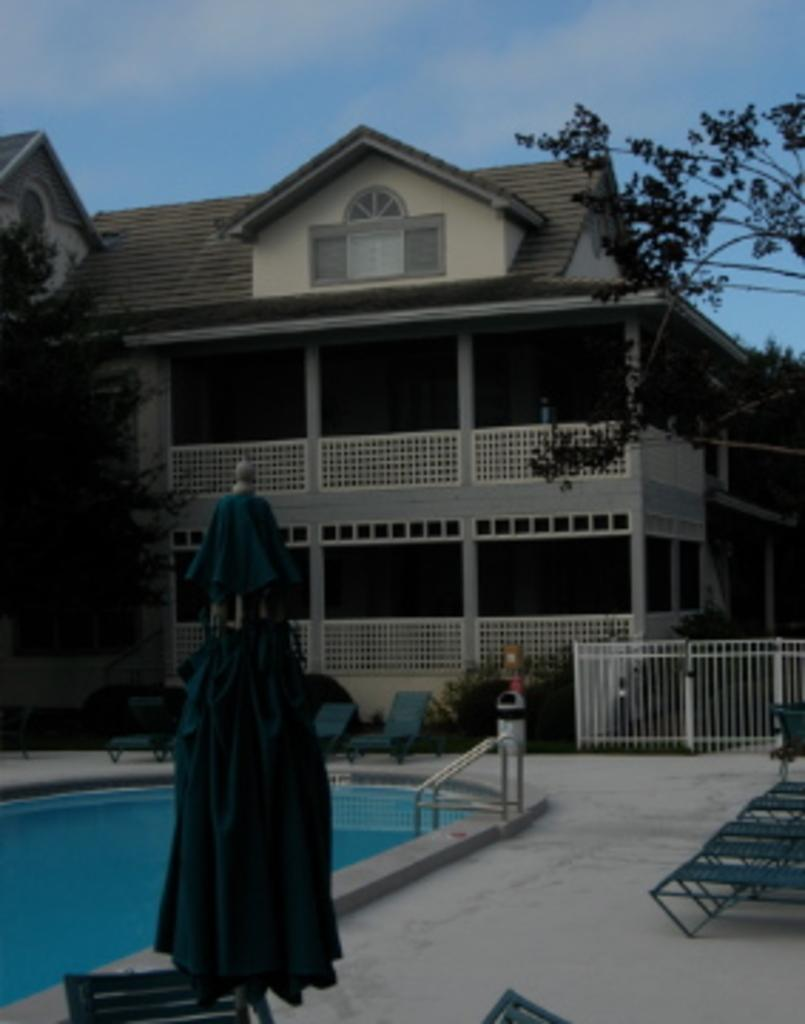What type of structure is located on the left side of the image? There is a swimming pool on the left side of the image. What can be seen in the middle of the image? There is a building in the middle of the image. What is visible at the top of the image? The sky is visible at the top of the image. How many boots are present in the image? There are no boots visible in the image. What type of pest can be seen in the image? There are no pests present in the image. 